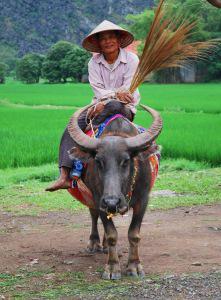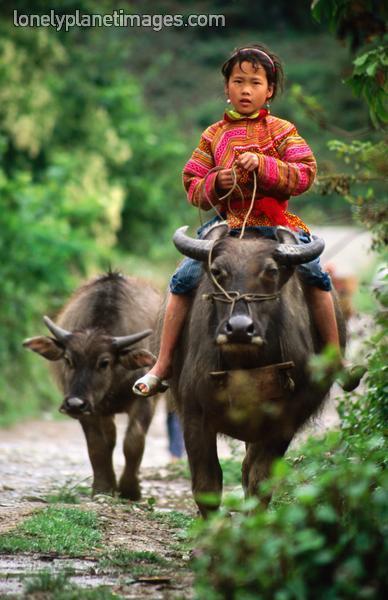The first image is the image on the left, the second image is the image on the right. Examine the images to the left and right. Is the description "There are exactly two people riding on animals." accurate? Answer yes or no. Yes. The first image is the image on the left, the second image is the image on the right. For the images displayed, is the sentence "There is exactly one person riding a water buffalo in each image." factually correct? Answer yes or no. Yes. 